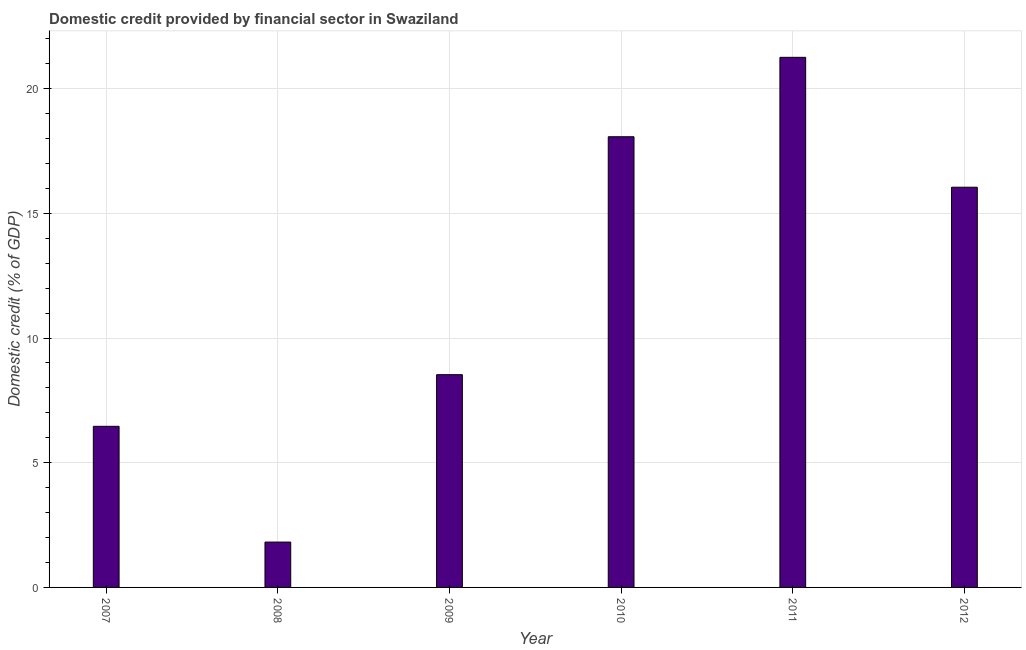What is the title of the graph?
Ensure brevity in your answer.  Domestic credit provided by financial sector in Swaziland. What is the label or title of the X-axis?
Offer a terse response. Year. What is the label or title of the Y-axis?
Offer a terse response. Domestic credit (% of GDP). What is the domestic credit provided by financial sector in 2010?
Keep it short and to the point. 18.07. Across all years, what is the maximum domestic credit provided by financial sector?
Your answer should be very brief. 21.26. Across all years, what is the minimum domestic credit provided by financial sector?
Give a very brief answer. 1.82. In which year was the domestic credit provided by financial sector maximum?
Offer a very short reply. 2011. In which year was the domestic credit provided by financial sector minimum?
Make the answer very short. 2008. What is the sum of the domestic credit provided by financial sector?
Your answer should be very brief. 72.19. What is the difference between the domestic credit provided by financial sector in 2008 and 2010?
Keep it short and to the point. -16.25. What is the average domestic credit provided by financial sector per year?
Your answer should be compact. 12.03. What is the median domestic credit provided by financial sector?
Your answer should be compact. 12.29. In how many years, is the domestic credit provided by financial sector greater than 20 %?
Provide a short and direct response. 1. What is the ratio of the domestic credit provided by financial sector in 2008 to that in 2011?
Give a very brief answer. 0.09. Is the domestic credit provided by financial sector in 2007 less than that in 2011?
Your answer should be compact. Yes. Is the difference between the domestic credit provided by financial sector in 2007 and 2009 greater than the difference between any two years?
Keep it short and to the point. No. What is the difference between the highest and the second highest domestic credit provided by financial sector?
Your answer should be very brief. 3.19. Is the sum of the domestic credit provided by financial sector in 2007 and 2010 greater than the maximum domestic credit provided by financial sector across all years?
Make the answer very short. Yes. What is the difference between the highest and the lowest domestic credit provided by financial sector?
Your answer should be very brief. 19.44. How many bars are there?
Make the answer very short. 6. Are all the bars in the graph horizontal?
Make the answer very short. No. How many years are there in the graph?
Your response must be concise. 6. What is the difference between two consecutive major ticks on the Y-axis?
Make the answer very short. 5. Are the values on the major ticks of Y-axis written in scientific E-notation?
Give a very brief answer. No. What is the Domestic credit (% of GDP) of 2007?
Give a very brief answer. 6.46. What is the Domestic credit (% of GDP) in 2008?
Provide a short and direct response. 1.82. What is the Domestic credit (% of GDP) in 2009?
Offer a terse response. 8.53. What is the Domestic credit (% of GDP) of 2010?
Your answer should be compact. 18.07. What is the Domestic credit (% of GDP) in 2011?
Keep it short and to the point. 21.26. What is the Domestic credit (% of GDP) in 2012?
Your response must be concise. 16.05. What is the difference between the Domestic credit (% of GDP) in 2007 and 2008?
Provide a short and direct response. 4.64. What is the difference between the Domestic credit (% of GDP) in 2007 and 2009?
Give a very brief answer. -2.07. What is the difference between the Domestic credit (% of GDP) in 2007 and 2010?
Give a very brief answer. -11.61. What is the difference between the Domestic credit (% of GDP) in 2007 and 2011?
Offer a terse response. -14.8. What is the difference between the Domestic credit (% of GDP) in 2007 and 2012?
Your response must be concise. -9.59. What is the difference between the Domestic credit (% of GDP) in 2008 and 2009?
Give a very brief answer. -6.71. What is the difference between the Domestic credit (% of GDP) in 2008 and 2010?
Offer a terse response. -16.25. What is the difference between the Domestic credit (% of GDP) in 2008 and 2011?
Offer a terse response. -19.44. What is the difference between the Domestic credit (% of GDP) in 2008 and 2012?
Your answer should be compact. -14.23. What is the difference between the Domestic credit (% of GDP) in 2009 and 2010?
Your answer should be very brief. -9.54. What is the difference between the Domestic credit (% of GDP) in 2009 and 2011?
Keep it short and to the point. -12.73. What is the difference between the Domestic credit (% of GDP) in 2009 and 2012?
Provide a short and direct response. -7.52. What is the difference between the Domestic credit (% of GDP) in 2010 and 2011?
Your response must be concise. -3.18. What is the difference between the Domestic credit (% of GDP) in 2010 and 2012?
Provide a short and direct response. 2.02. What is the difference between the Domestic credit (% of GDP) in 2011 and 2012?
Give a very brief answer. 5.21. What is the ratio of the Domestic credit (% of GDP) in 2007 to that in 2008?
Provide a short and direct response. 3.55. What is the ratio of the Domestic credit (% of GDP) in 2007 to that in 2009?
Ensure brevity in your answer.  0.76. What is the ratio of the Domestic credit (% of GDP) in 2007 to that in 2010?
Offer a very short reply. 0.36. What is the ratio of the Domestic credit (% of GDP) in 2007 to that in 2011?
Make the answer very short. 0.3. What is the ratio of the Domestic credit (% of GDP) in 2007 to that in 2012?
Ensure brevity in your answer.  0.4. What is the ratio of the Domestic credit (% of GDP) in 2008 to that in 2009?
Provide a short and direct response. 0.21. What is the ratio of the Domestic credit (% of GDP) in 2008 to that in 2010?
Provide a short and direct response. 0.1. What is the ratio of the Domestic credit (% of GDP) in 2008 to that in 2011?
Offer a terse response. 0.09. What is the ratio of the Domestic credit (% of GDP) in 2008 to that in 2012?
Offer a very short reply. 0.11. What is the ratio of the Domestic credit (% of GDP) in 2009 to that in 2010?
Provide a short and direct response. 0.47. What is the ratio of the Domestic credit (% of GDP) in 2009 to that in 2011?
Your response must be concise. 0.4. What is the ratio of the Domestic credit (% of GDP) in 2009 to that in 2012?
Make the answer very short. 0.53. What is the ratio of the Domestic credit (% of GDP) in 2010 to that in 2011?
Provide a succinct answer. 0.85. What is the ratio of the Domestic credit (% of GDP) in 2010 to that in 2012?
Offer a very short reply. 1.13. What is the ratio of the Domestic credit (% of GDP) in 2011 to that in 2012?
Your answer should be very brief. 1.32. 